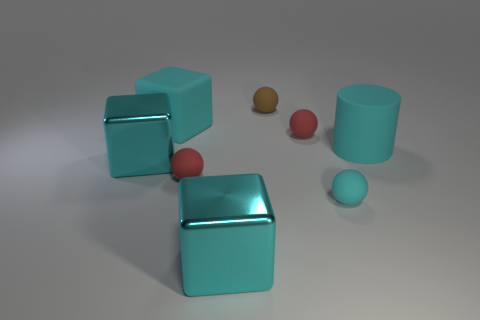Add 2 tiny brown spheres. How many objects exist? 10 Subtract all blocks. How many objects are left? 5 Subtract all small red spheres. Subtract all large objects. How many objects are left? 2 Add 4 cyan metallic blocks. How many cyan metallic blocks are left? 6 Add 7 big cyan rubber cylinders. How many big cyan rubber cylinders exist? 8 Subtract 0 red cylinders. How many objects are left? 8 